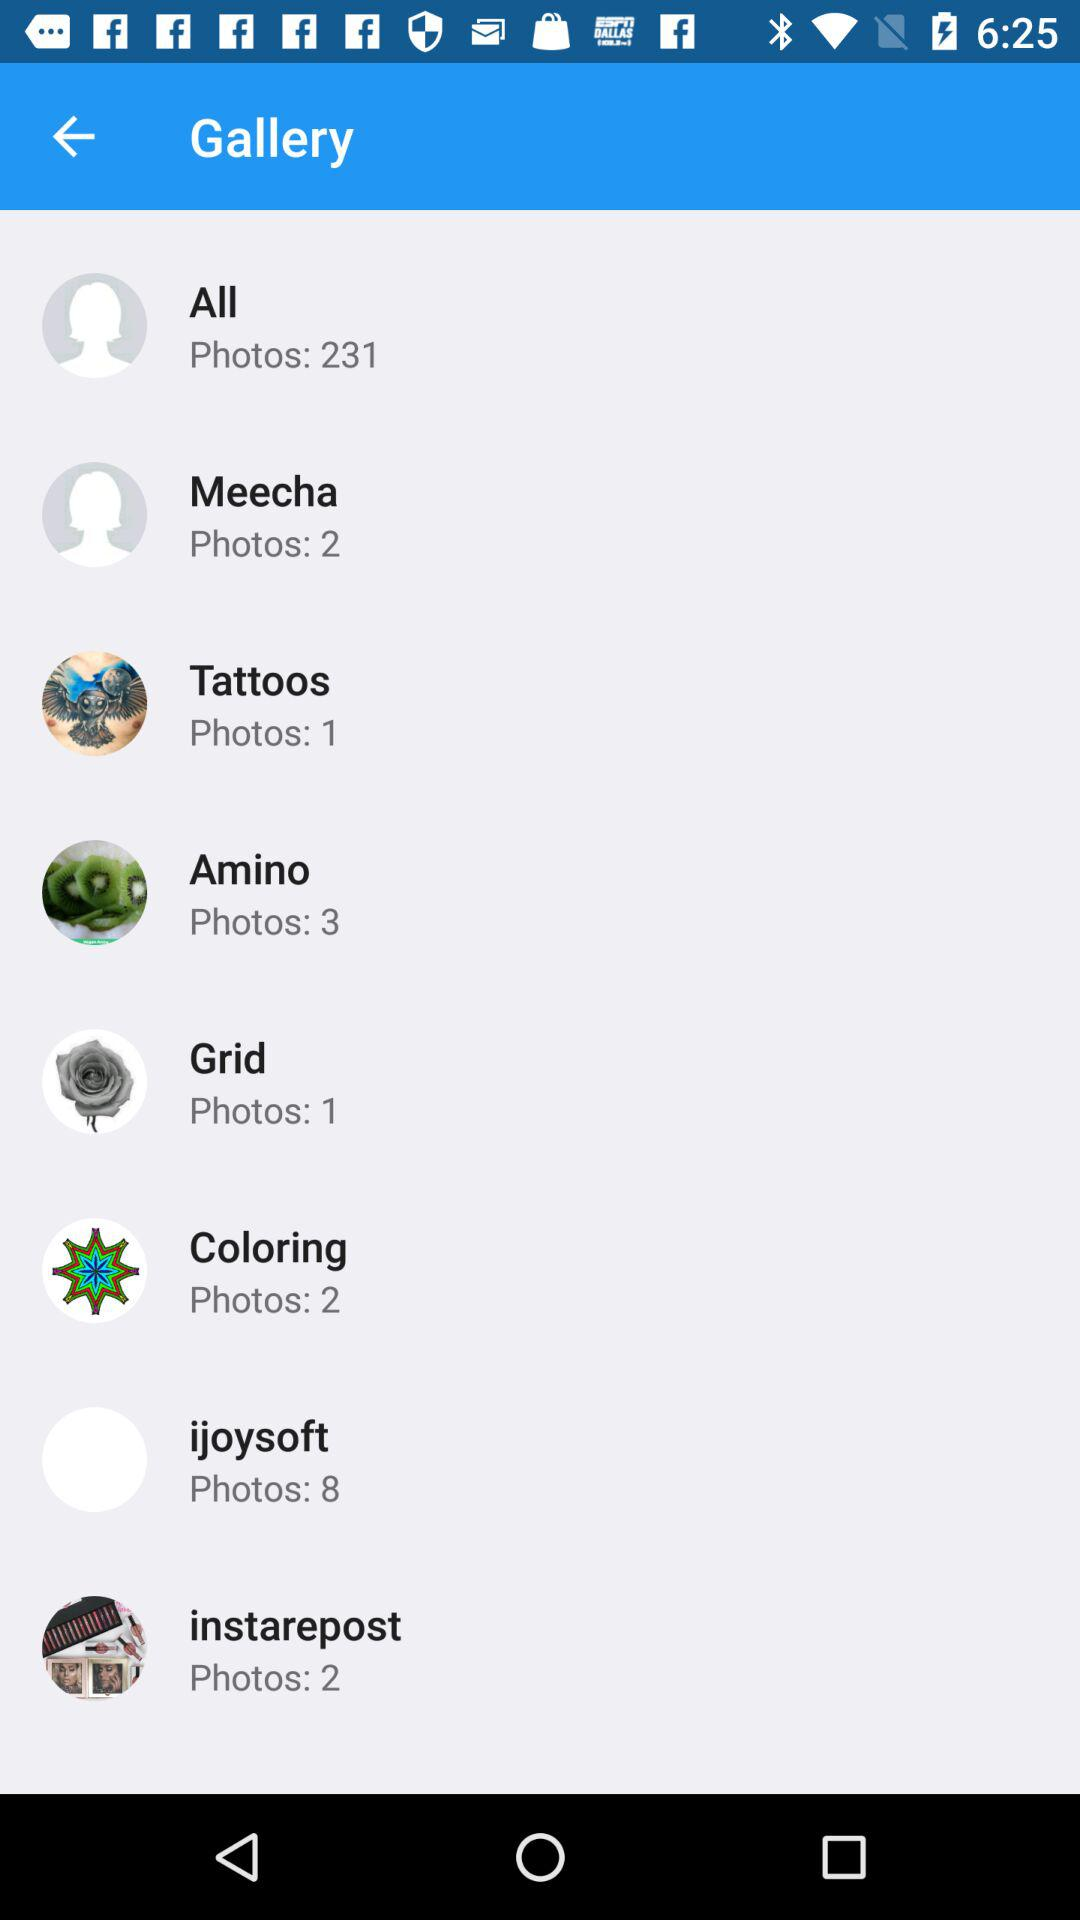How many photos are there in "Tattoos"? There is 1 photo in "Tattoos". 